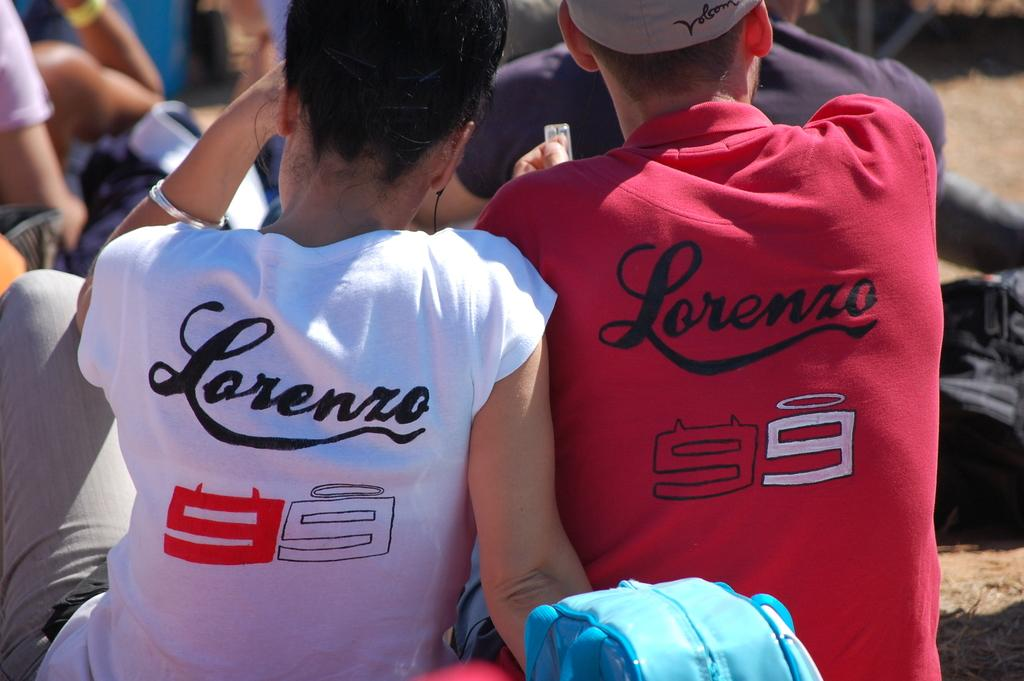Provide a one-sentence caption for the provided image. A young couple wearing a white and a red tshirt that says Lorenzo 99. 